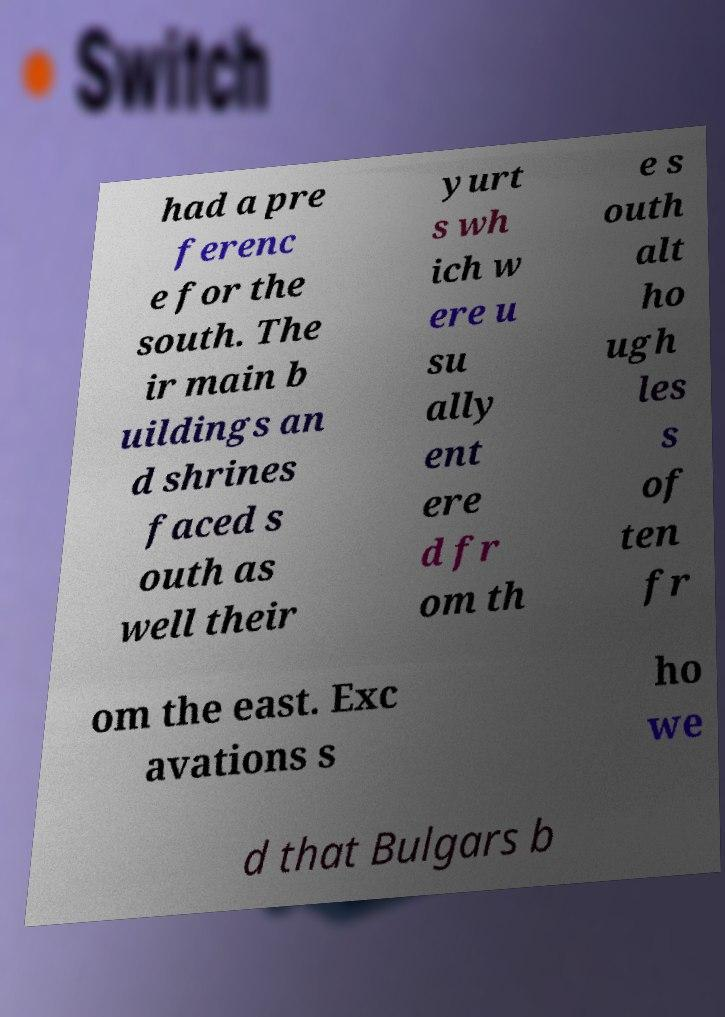Please identify and transcribe the text found in this image. had a pre ferenc e for the south. The ir main b uildings an d shrines faced s outh as well their yurt s wh ich w ere u su ally ent ere d fr om th e s outh alt ho ugh les s of ten fr om the east. Exc avations s ho we d that Bulgars b 